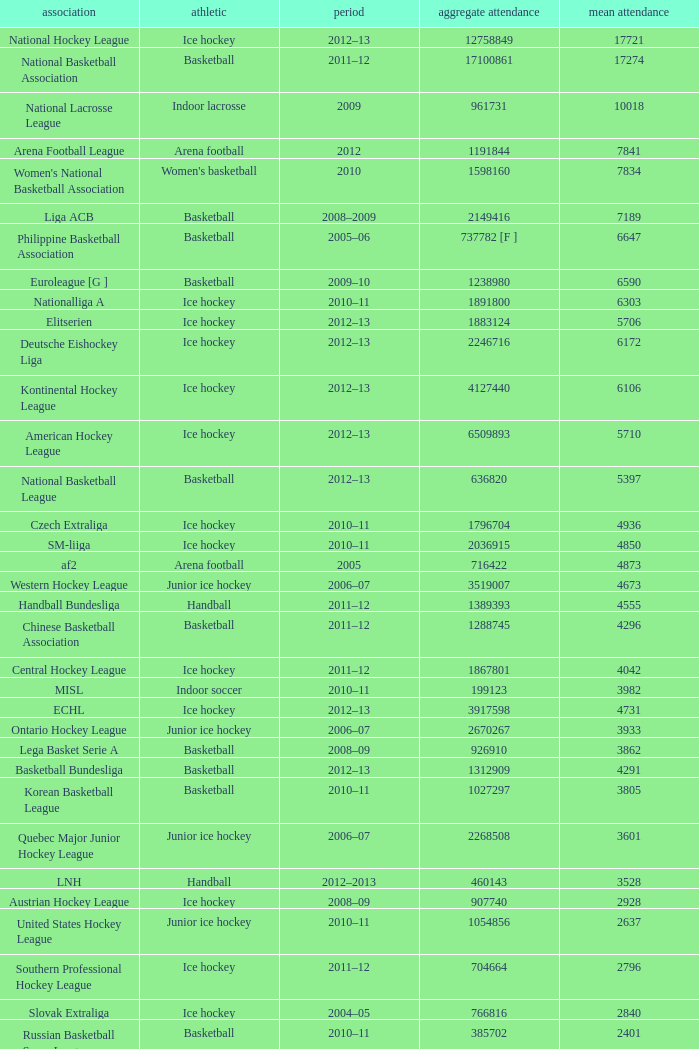What's the average attendance of the league with a total attendance of 2268508? 3601.0. 